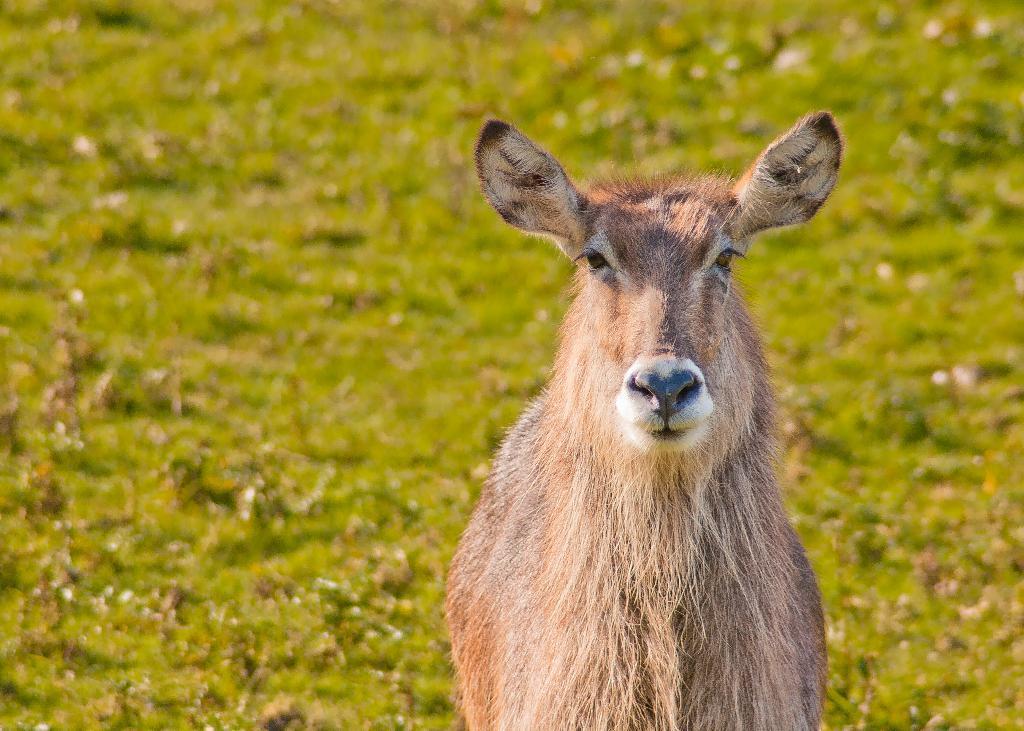How would you summarize this image in a sentence or two? In this image we can see a deer. 